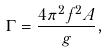<formula> <loc_0><loc_0><loc_500><loc_500>\Gamma = \frac { 4 \pi ^ { 2 } f ^ { 2 } A } { g } ,</formula> 